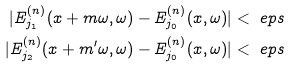<formula> <loc_0><loc_0><loc_500><loc_500>| E _ { j _ { 1 } } ^ { ( n ) } ( x + m \omega , \omega ) - E _ { j _ { 0 } } ^ { ( n ) } ( x , \omega ) | & < \ e p s \\ | E _ { j _ { 2 } } ^ { ( n ) } ( x + m ^ { \prime } \omega , \omega ) - E _ { j _ { 0 } } ^ { ( n ) } ( x , \omega ) | & < \ e p s</formula> 